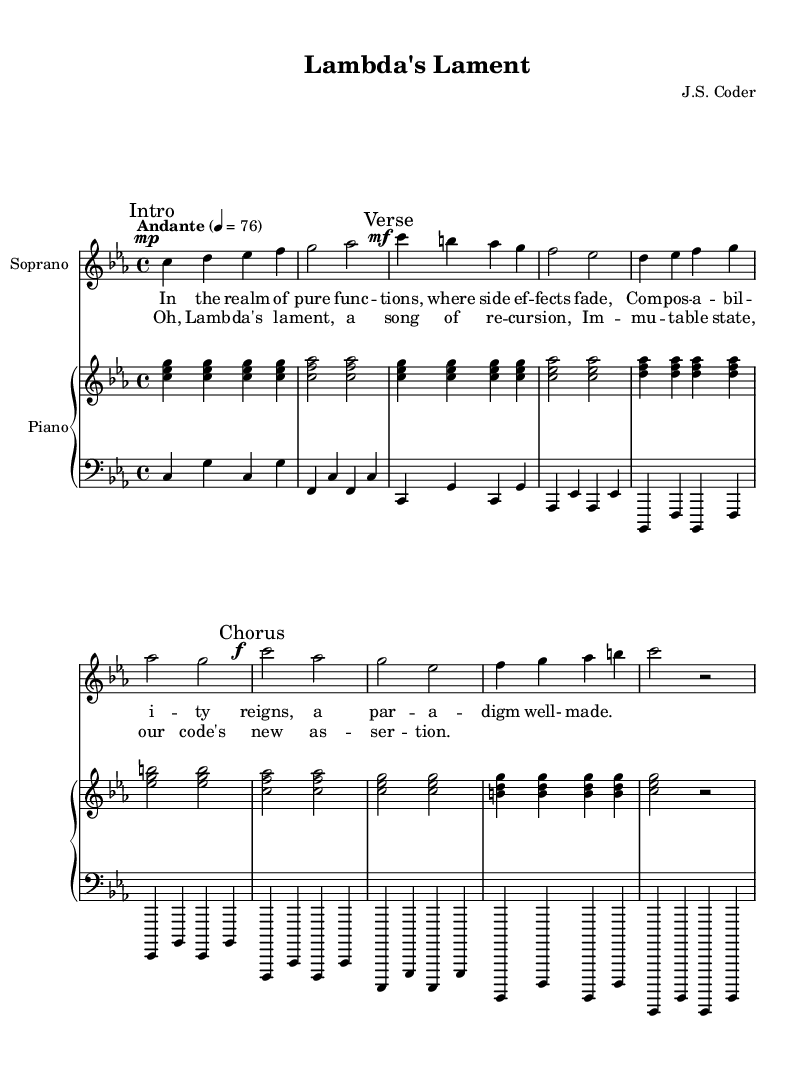What is the key signature of this music? The key signature is indicated at the beginning of the score and shows the flats or sharps. In this case, it’s C minor, which has three flats (B flat, E flat, and A flat).
Answer: C minor What is the time signature of the piece? The time signature is located at the beginning of the score, represented as a fraction. Here, it is 4/4, indicating four beats per measure with a quarter note receiving one beat.
Answer: 4/4 What is the tempo marking for this composition? The tempo marking is found at the beginning of the score and indicates how fast the piece should be played. In this case, it is marked as "Andante," meaning a moderately slow tempo.
Answer: Andante How many measures are in the verse section? By counting the measures in the section labeled "Verse," we focus on the measures that are part of that section specifically. There are four measures in the verse.
Answer: Four What vocal range is used for the soprano part? The soprano part is written with a treble clef, typically indicating a higher vocal range. Based on the notes presented, it lies within the standard soprano range, often considered to be from middle C to A or higher.
Answer: Treble clef Which specific musical technique is mentioned in the lyrics? The lyrics of the opera reference the concept of "recursion," which is a programming technique where a function calls itself. This term is used metaphorically in the context of the music.
Answer: Recursion What is the dynamic marking at the chorus section? The dynamic marking at the chorus is indicated by the notation preceding the notes, specifically showing how loud or soft the music should be played. Here, the marking is "f," meaning forte or loud.
Answer: Forte 